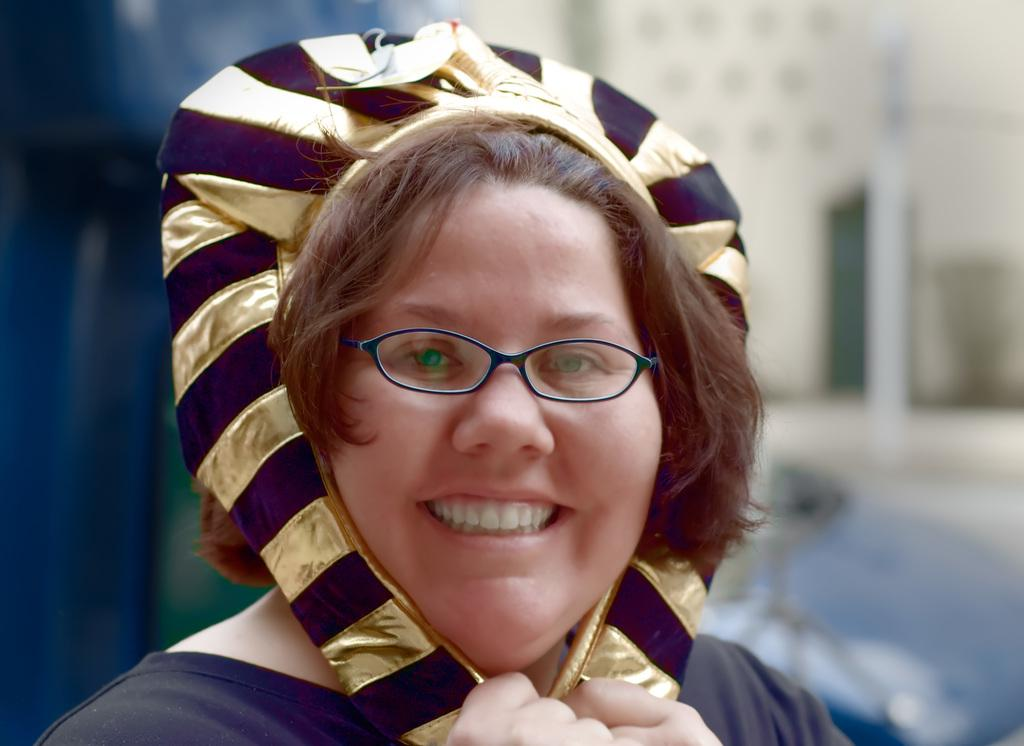Who is the main subject in the image? There is a woman in the image. What is the woman wearing on her head? The woman is wearing a cap. What accessory is the woman wearing on her face? The woman is wearing spectacles. What is the woman's facial expression in the image? The woman is smiling. How would you describe the background of the image? The background of the image is blurred. How many balls can be seen bouncing in the woman's stomach in the image? There are no balls or any reference to a stomach in the image; it features a woman wearing a cap, spectacles, and smiling. 